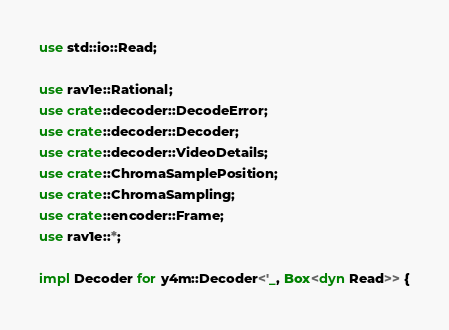<code> <loc_0><loc_0><loc_500><loc_500><_Rust_>use std::io::Read;

use rav1e::Rational;
use crate::decoder::DecodeError;
use crate::decoder::Decoder;
use crate::decoder::VideoDetails;
use crate::ChromaSamplePosition;
use crate::ChromaSampling;
use crate::encoder::Frame;
use rav1e::*;

impl Decoder for y4m::Decoder<'_, Box<dyn Read>> {</code> 